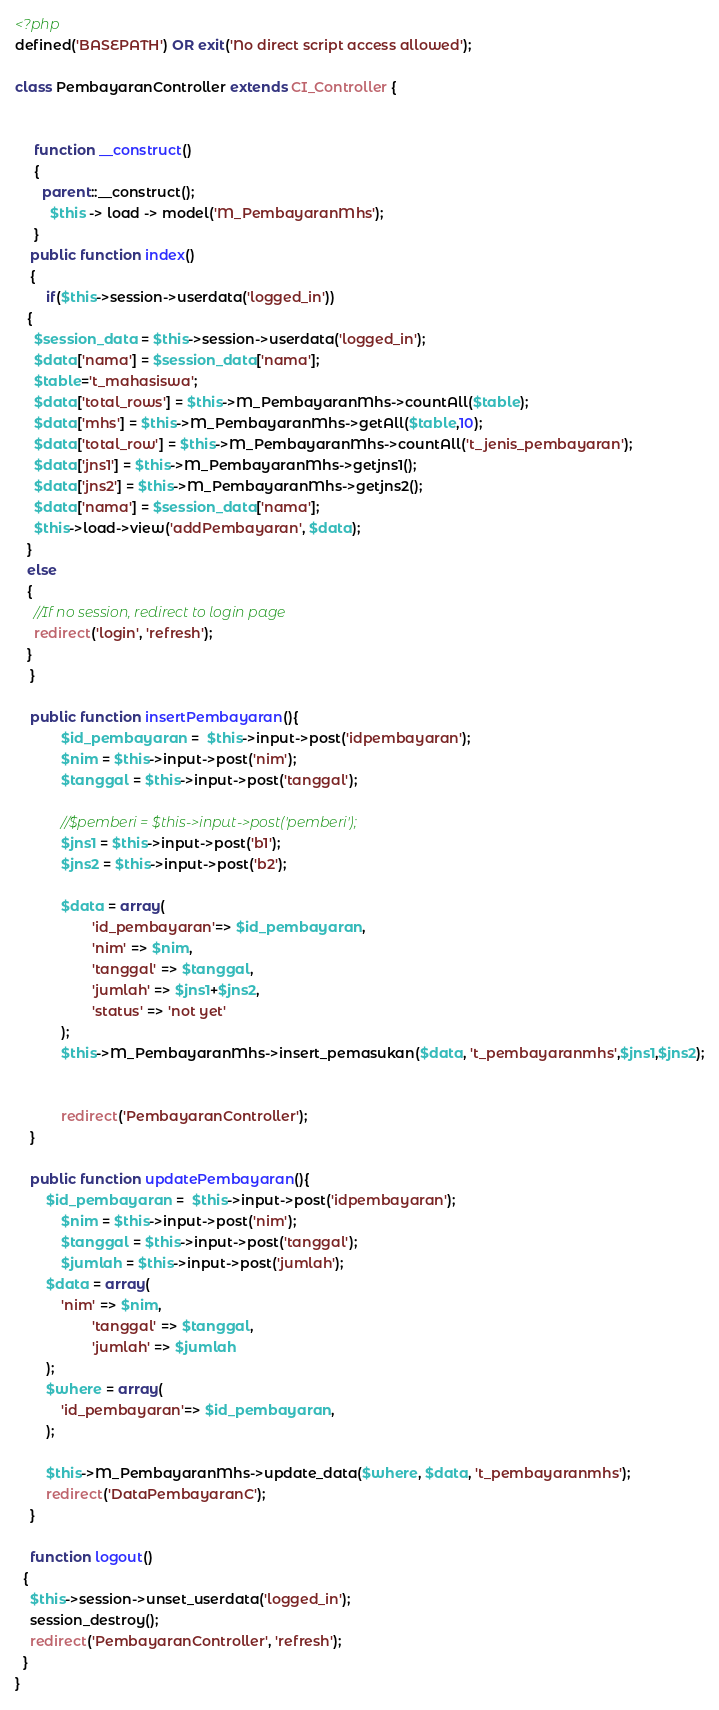Convert code to text. <code><loc_0><loc_0><loc_500><loc_500><_PHP_><?php
defined('BASEPATH') OR exit('No direct script access allowed');

class PembayaranController extends CI_Controller {


	 function __construct()
	 {
	   parent::__construct();
		 $this -> load -> model('M_PembayaranMhs');
	 }
	public function index()
	{
		if($this->session->userdata('logged_in'))
   {
     $session_data = $this->session->userdata('logged_in');
     $data['nama'] = $session_data['nama'];
	 $table='t_mahasiswa';
	 $data['total_rows'] = $this->M_PembayaranMhs->countAll($table);
	 $data['mhs'] = $this->M_PembayaranMhs->getAll($table,10);
	 $data['total_row'] = $this->M_PembayaranMhs->countAll('t_jenis_pembayaran');
	 $data['jns1'] = $this->M_PembayaranMhs->getjns1();
	 $data['jns2'] = $this->M_PembayaranMhs->getjns2();
	 $data['nama'] = $session_data['nama'];
     $this->load->view('addPembayaran', $data);
   }
   else
   {
     //If no session, redirect to login page
     redirect('login', 'refresh');
   }
	}

	public function insertPembayaran(){
			$id_pembayaran =  $this->input->post('idpembayaran');
			$nim = $this->input->post('nim');
			$tanggal = $this->input->post('tanggal');
			
			//$pemberi = $this->input->post('pemberi');
			$jns1 = $this->input->post('b1');
			$jns2 = $this->input->post('b2');
			
			$data = array(
					'id_pembayaran'=> $id_pembayaran,
					'nim' => $nim,
					'tanggal' => $tanggal,
					'jumlah' => $jns1+$jns2,
					'status' => 'not yet'
			);
			$this->M_PembayaranMhs->insert_pemasukan($data, 't_pembayaranmhs',$jns1,$jns2);
			
			
			redirect('PembayaranController');
	}

	public function updatePembayaran(){
		$id_pembayaran =  $this->input->post('idpembayaran');
			$nim = $this->input->post('nim');
			$tanggal = $this->input->post('tanggal');
			$jumlah = $this->input->post('jumlah');
		$data = array(
			'nim' => $nim,
					'tanggal' => $tanggal,
					'jumlah' => $jumlah
		);
		$where = array(
			'id_pembayaran'=> $id_pembayaran,
		);

		$this->M_PembayaranMhs->update_data($where, $data, 't_pembayaranmhs');
		redirect('DataPembayaranC');
	}

	function logout()
  {
    $this->session->unset_userdata('logged_in');
    session_destroy();
    redirect('PembayaranController', 'refresh');
  }
}
</code> 